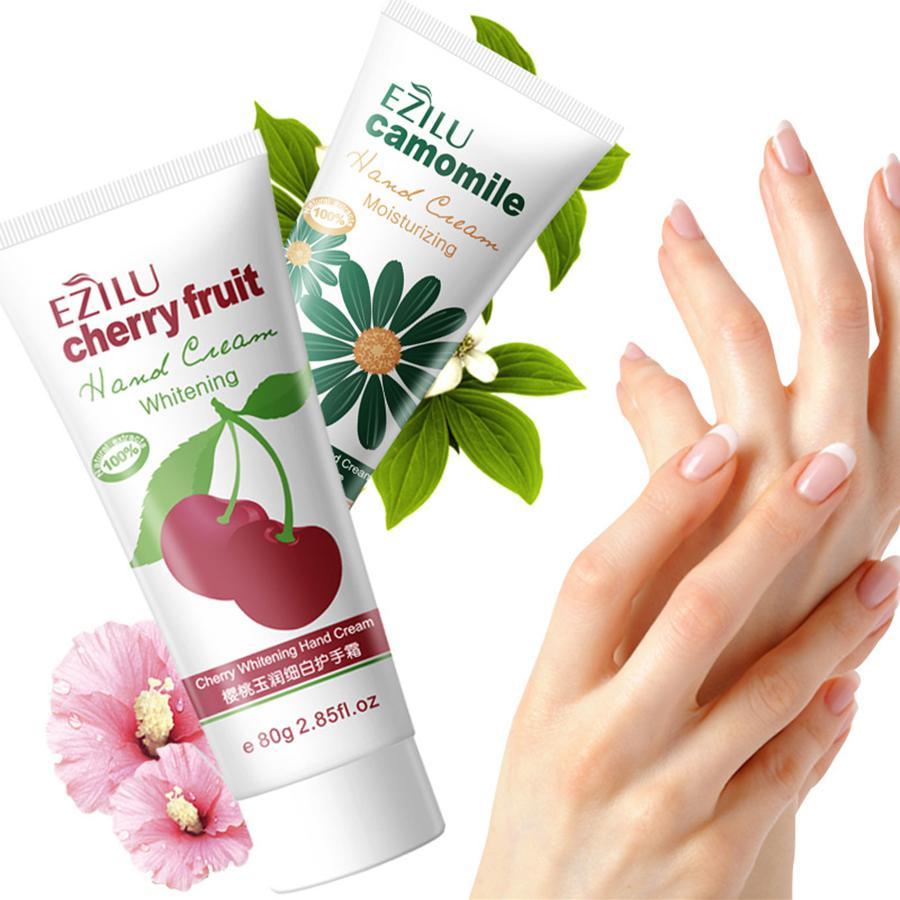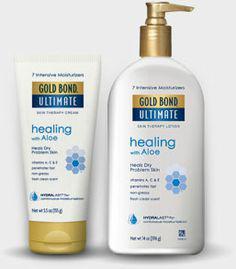The first image is the image on the left, the second image is the image on the right. Given the left and right images, does the statement "A box and a tube of whitening cream are in one image." hold true? Answer yes or no. No. 